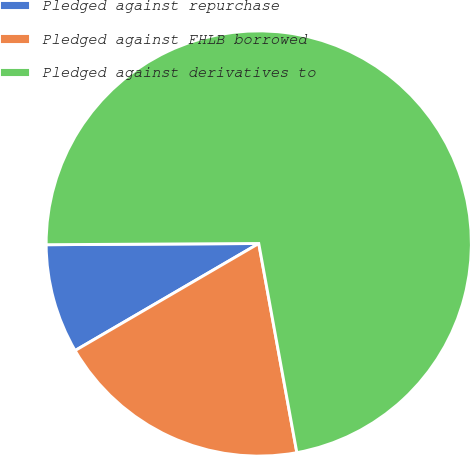<chart> <loc_0><loc_0><loc_500><loc_500><pie_chart><fcel>Pledged against repurchase<fcel>Pledged against FHLB borrowed<fcel>Pledged against derivatives to<nl><fcel>8.31%<fcel>19.47%<fcel>72.23%<nl></chart> 